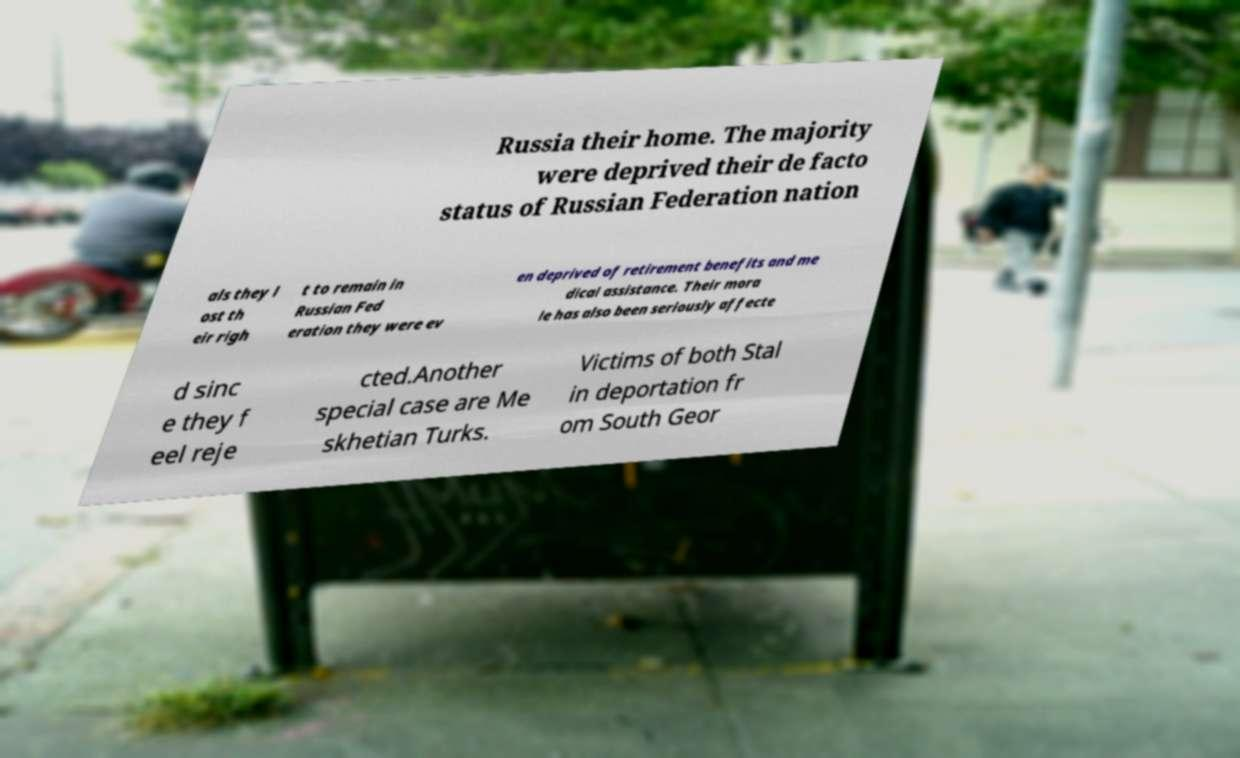For documentation purposes, I need the text within this image transcribed. Could you provide that? Russia their home. The majority were deprived their de facto status of Russian Federation nation als they l ost th eir righ t to remain in Russian Fed eration they were ev en deprived of retirement benefits and me dical assistance. Their mora le has also been seriously affecte d sinc e they f eel reje cted.Another special case are Me skhetian Turks. Victims of both Stal in deportation fr om South Geor 